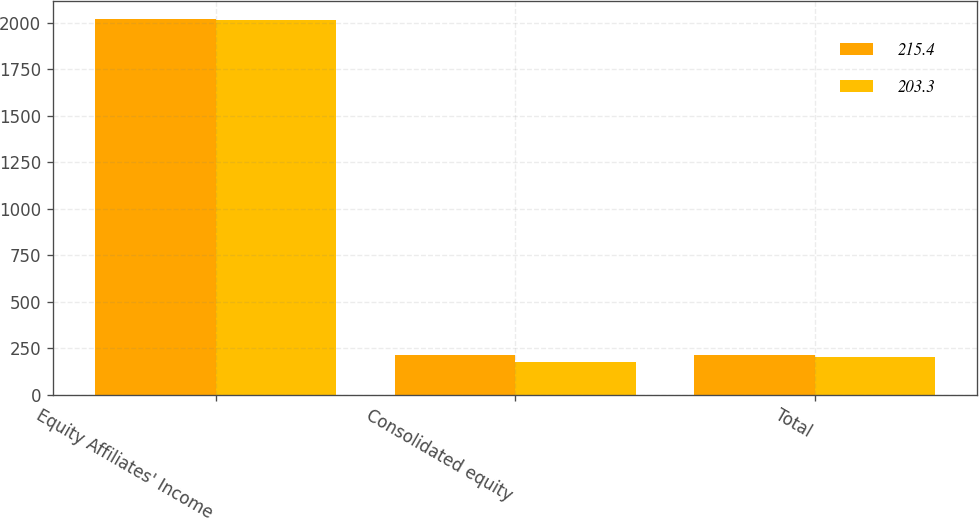Convert chart. <chart><loc_0><loc_0><loc_500><loc_500><stacked_bar_chart><ecel><fcel>Equity Affiliates' Income<fcel>Consolidated equity<fcel>Total<nl><fcel>215.4<fcel>2019<fcel>215.4<fcel>215.4<nl><fcel>203.3<fcel>2018<fcel>174.8<fcel>203.3<nl></chart> 